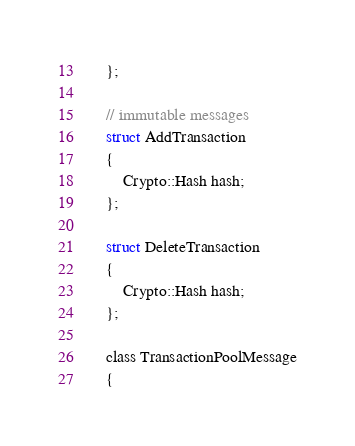Convert code to text. <code><loc_0><loc_0><loc_500><loc_500><_C_>    };

    // immutable messages
    struct AddTransaction
    {
        Crypto::Hash hash;
    };

    struct DeleteTransaction
    {
        Crypto::Hash hash;
    };

    class TransactionPoolMessage
    {</code> 